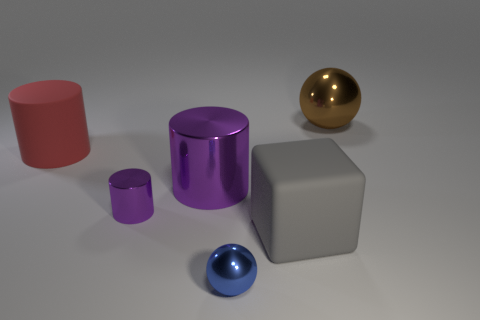Subtract all rubber cylinders. How many cylinders are left? 2 Subtract all red cylinders. How many cylinders are left? 2 Add 4 big matte cylinders. How many objects exist? 10 Subtract all green balls. How many red cylinders are left? 1 Add 5 small blue metal objects. How many small blue metal objects exist? 6 Subtract 0 yellow blocks. How many objects are left? 6 Subtract all cubes. How many objects are left? 5 Subtract 1 balls. How many balls are left? 1 Subtract all blue blocks. Subtract all brown balls. How many blocks are left? 1 Subtract all tiny green rubber balls. Subtract all brown things. How many objects are left? 5 